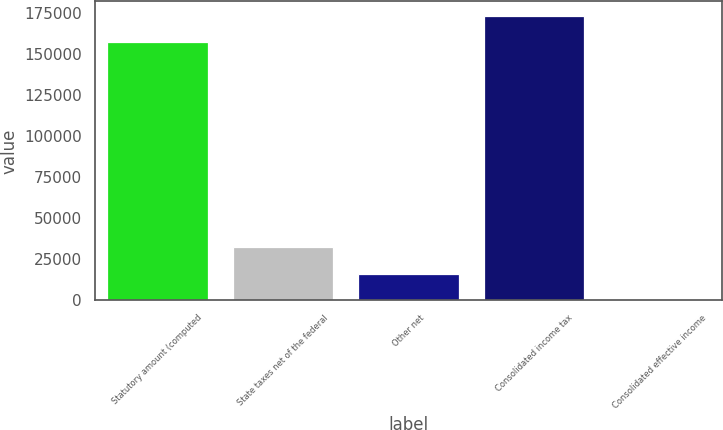<chart> <loc_0><loc_0><loc_500><loc_500><bar_chart><fcel>Statutory amount (computed<fcel>State taxes net of the federal<fcel>Other net<fcel>Consolidated income tax<fcel>Consolidated effective income<nl><fcel>157025<fcel>32331.2<fcel>16183.6<fcel>173173<fcel>36<nl></chart> 